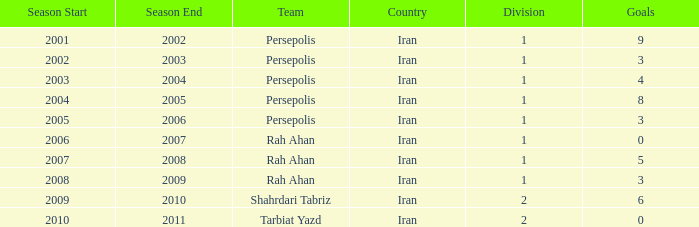Help me parse the entirety of this table. {'header': ['Season Start', 'Season End', 'Team', 'Country', 'Division', 'Goals'], 'rows': [['2001', '2002', 'Persepolis', 'Iran', '1', '9'], ['2002', '2003', 'Persepolis', 'Iran', '1', '3'], ['2003', '2004', 'Persepolis', 'Iran', '1', '4'], ['2004', '2005', 'Persepolis', 'Iran', '1', '8'], ['2005', '2006', 'Persepolis', 'Iran', '1', '3'], ['2006', '2007', 'Rah Ahan', 'Iran', '1', '0'], ['2007', '2008', 'Rah Ahan', 'Iran', '1', '5'], ['2008', '2009', 'Rah Ahan', 'Iran', '1', '3'], ['2009', '2010', 'Shahrdari Tabriz', 'Iran', '2', '6'], ['2010', '2011', 'Tarbiat Yazd', 'Iran', '2', '0']]} What is Season, when Goals is less than 6, and when Team is "Tarbiat Yazd"? 2010-11. 